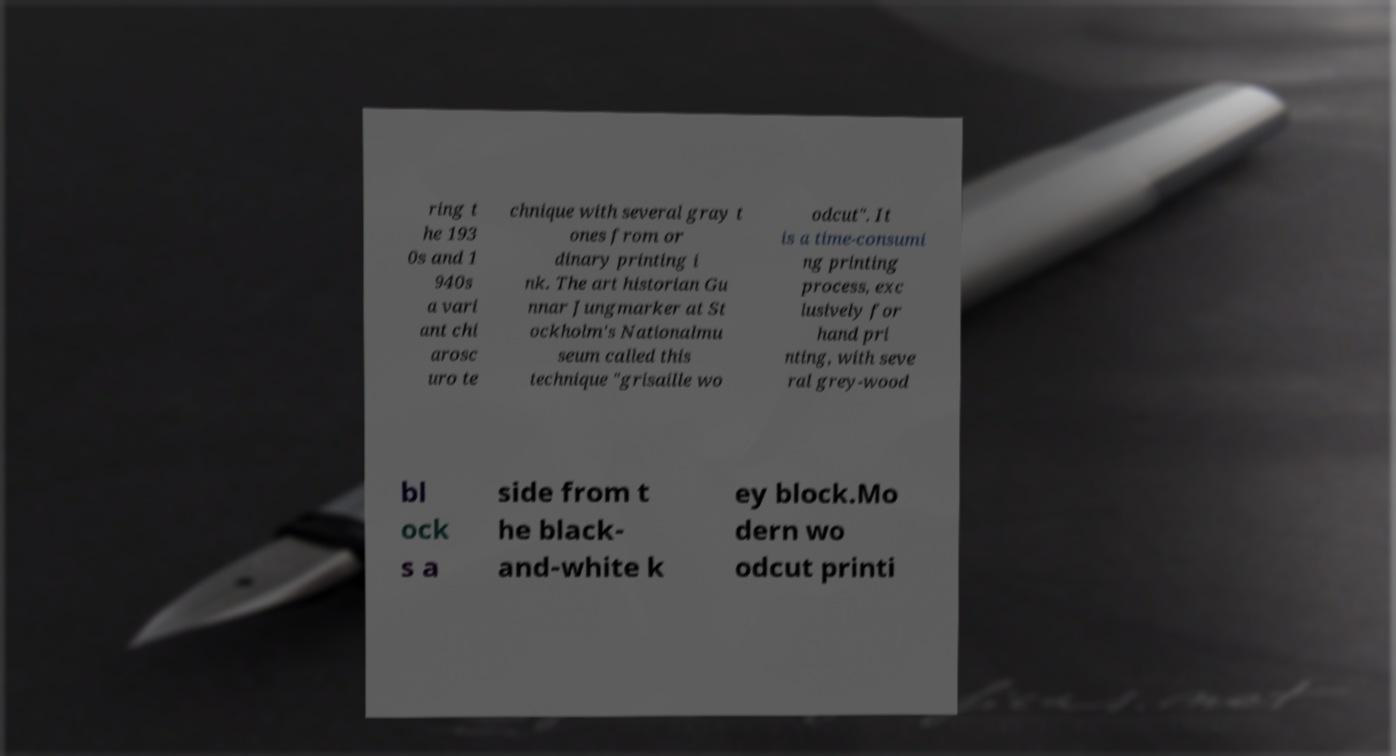There's text embedded in this image that I need extracted. Can you transcribe it verbatim? ring t he 193 0s and 1 940s a vari ant chi arosc uro te chnique with several gray t ones from or dinary printing i nk. The art historian Gu nnar Jungmarker at St ockholm's Nationalmu seum called this technique "grisaille wo odcut". It is a time-consumi ng printing process, exc lusively for hand pri nting, with seve ral grey-wood bl ock s a side from t he black- and-white k ey block.Mo dern wo odcut printi 